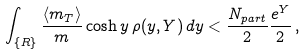Convert formula to latex. <formula><loc_0><loc_0><loc_500><loc_500>\int _ { \{ R \} } \frac { \langle m _ { T } \rangle } { m } \cosh y \, \rho ( y , Y ) \, d y < \frac { N _ { p a r t } } { 2 } \frac { e ^ { Y } } { 2 } \, ,</formula> 